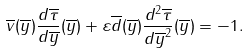<formula> <loc_0><loc_0><loc_500><loc_500>\overline { v } ( \overline { y } ) \frac { d \overline { \tau } } { d \overline { y } } ( \overline { y } ) + \varepsilon \overline { d } ( \overline { y } ) \frac { d ^ { 2 } \overline { \tau } } { d \overline { y } ^ { 2 } } ( \overline { y } ) = - 1 .</formula> 